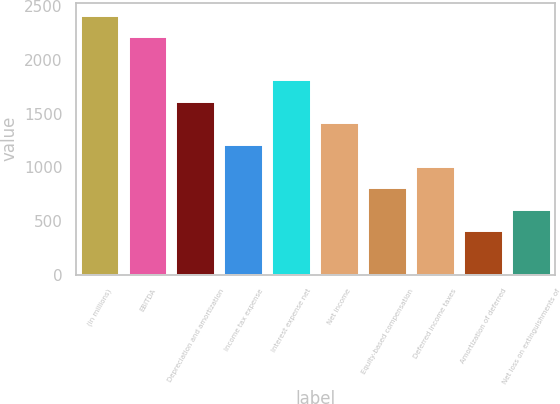Convert chart to OTSL. <chart><loc_0><loc_0><loc_500><loc_500><bar_chart><fcel>(in millions)<fcel>EBITDA<fcel>Depreciation and amortization<fcel>Income tax expense<fcel>Interest expense net<fcel>Net income<fcel>Equity-based compensation<fcel>Deferred income taxes<fcel>Amortization of deferred<fcel>Net loss on extinguishments of<nl><fcel>2414.2<fcel>2213.1<fcel>1609.8<fcel>1207.6<fcel>1810.9<fcel>1408.7<fcel>805.4<fcel>1006.5<fcel>403.2<fcel>604.3<nl></chart> 